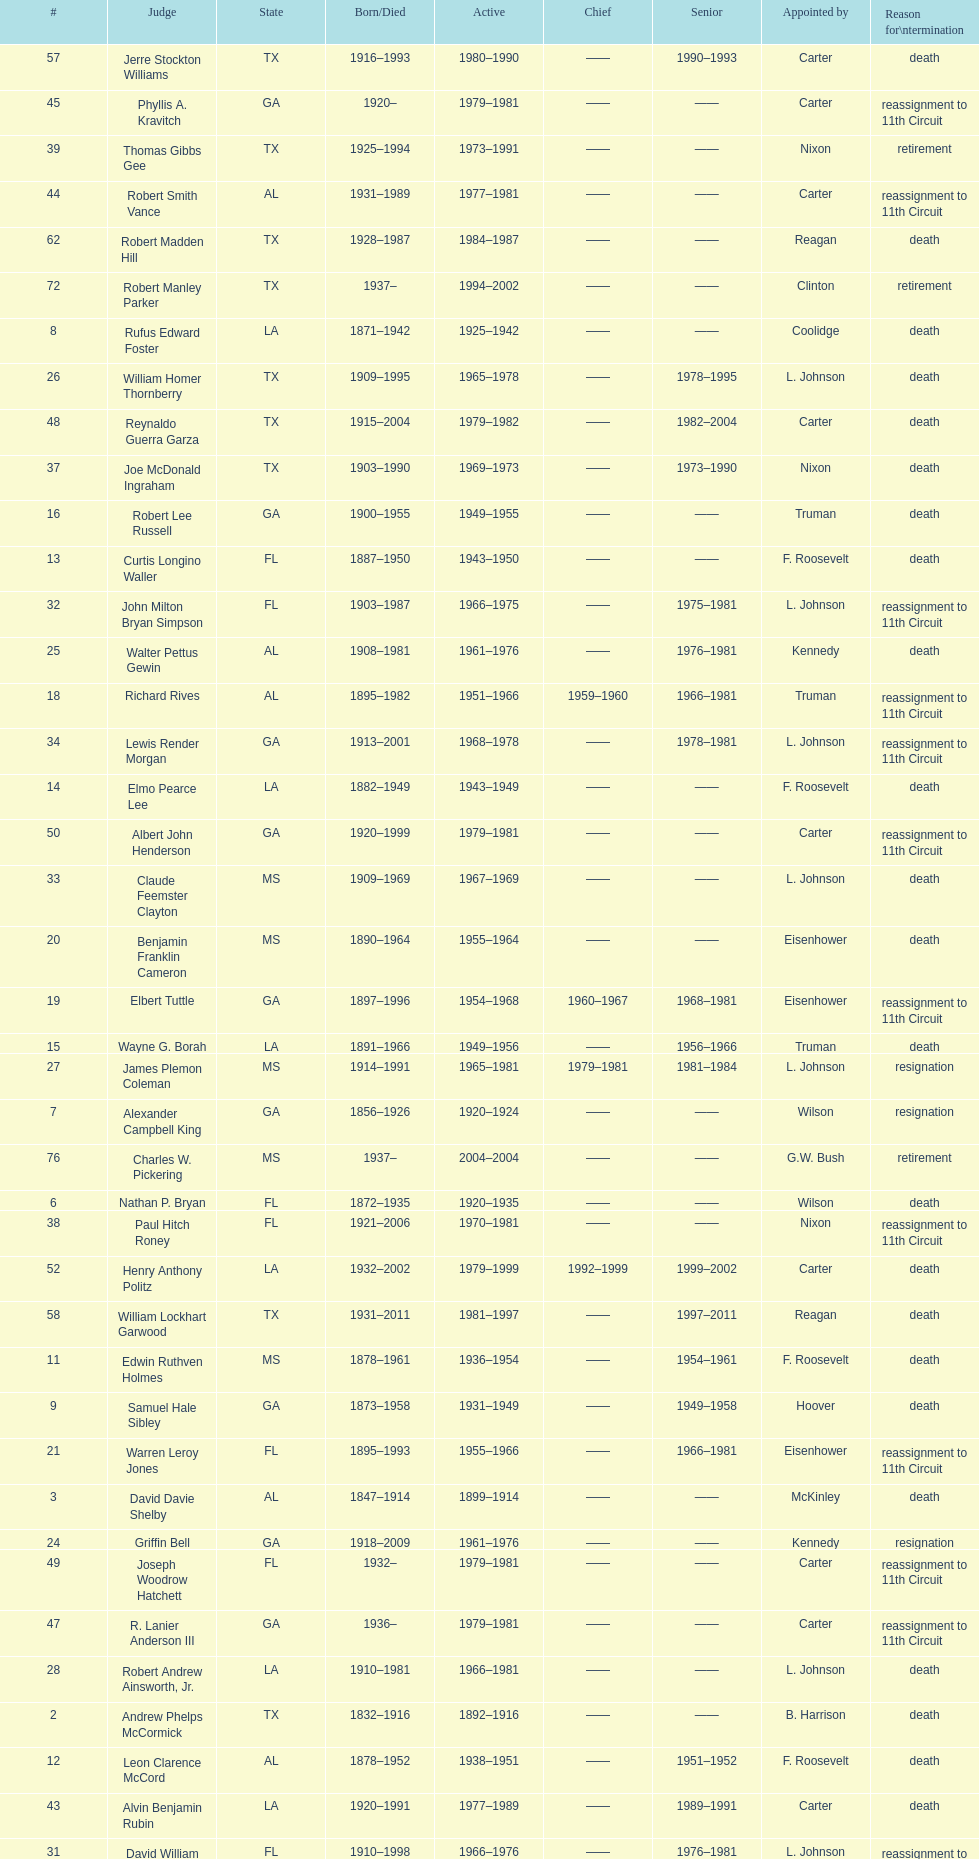How many judges were appointed by president carter? 13. 